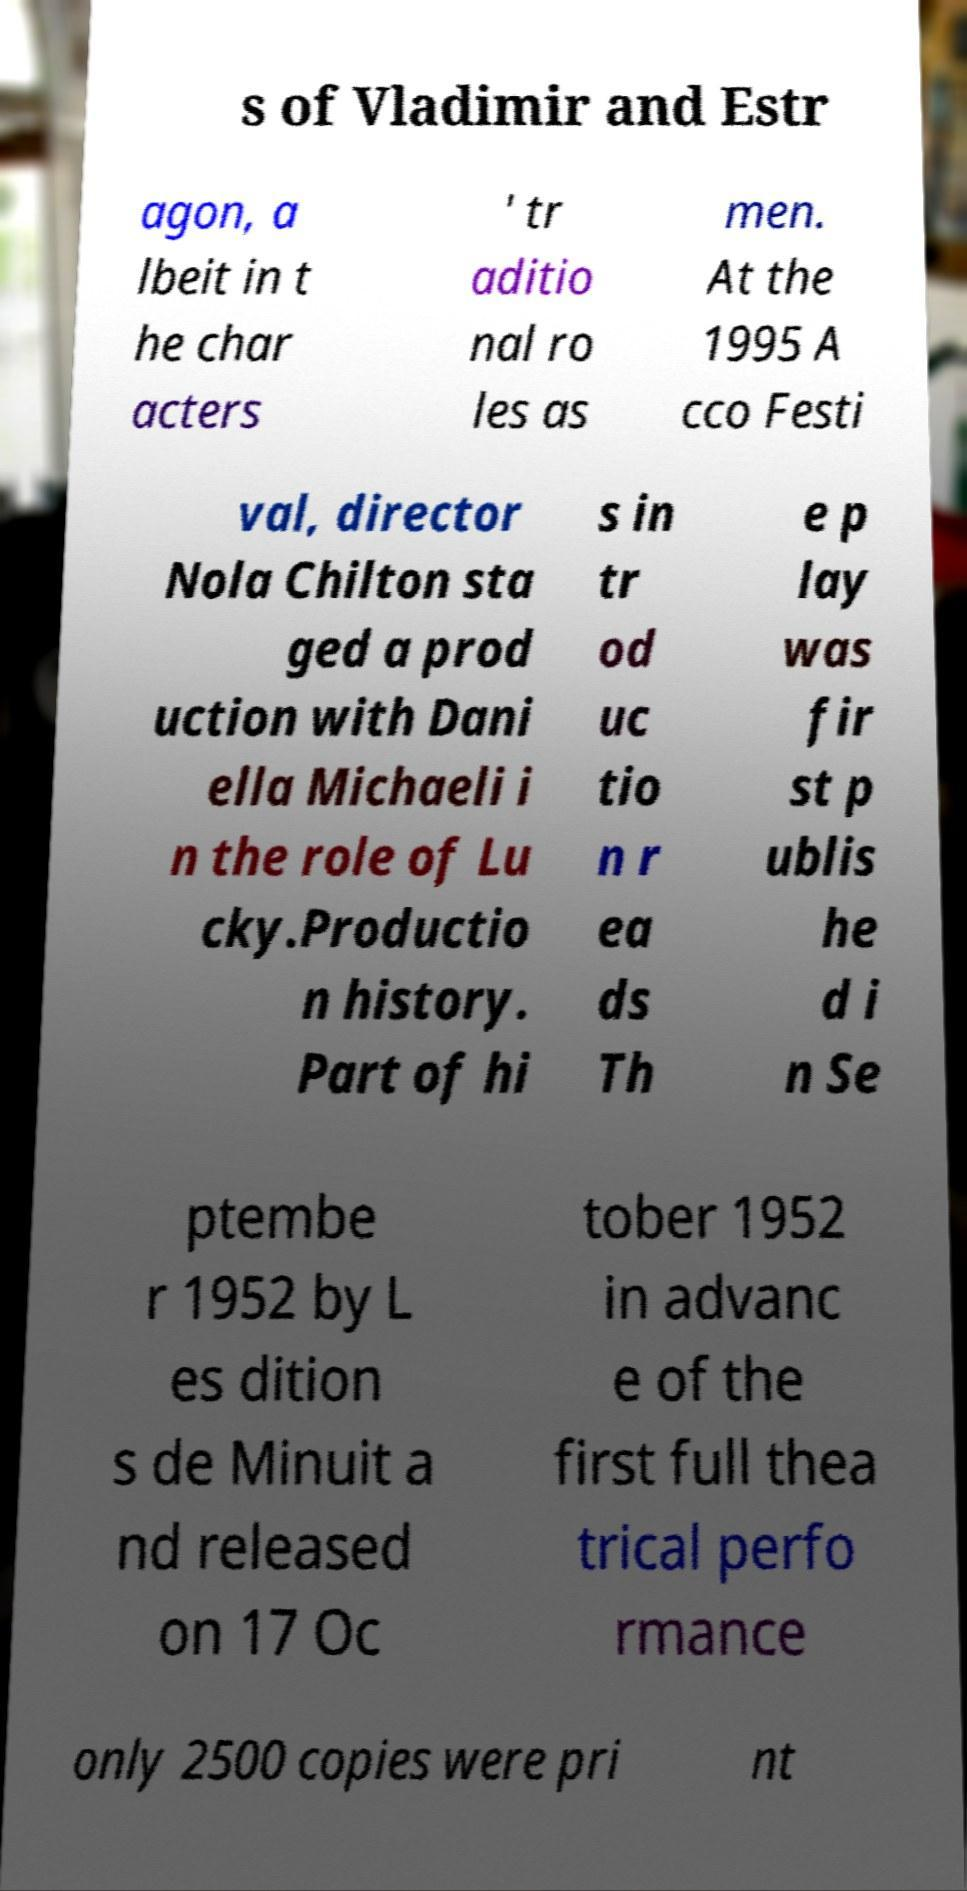Could you extract and type out the text from this image? s of Vladimir and Estr agon, a lbeit in t he char acters ' tr aditio nal ro les as men. At the 1995 A cco Festi val, director Nola Chilton sta ged a prod uction with Dani ella Michaeli i n the role of Lu cky.Productio n history. Part of hi s in tr od uc tio n r ea ds Th e p lay was fir st p ublis he d i n Se ptembe r 1952 by L es dition s de Minuit a nd released on 17 Oc tober 1952 in advanc e of the first full thea trical perfo rmance only 2500 copies were pri nt 